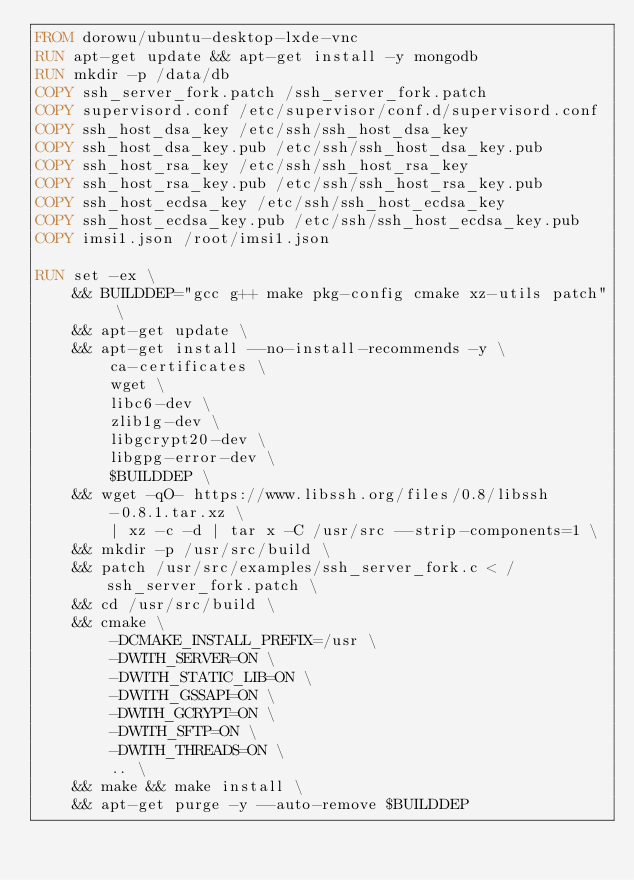<code> <loc_0><loc_0><loc_500><loc_500><_Dockerfile_>FROM dorowu/ubuntu-desktop-lxde-vnc
RUN apt-get update && apt-get install -y mongodb
RUN mkdir -p /data/db
COPY ssh_server_fork.patch /ssh_server_fork.patch
COPY supervisord.conf /etc/supervisor/conf.d/supervisord.conf
COPY ssh_host_dsa_key /etc/ssh/ssh_host_dsa_key
COPY ssh_host_dsa_key.pub /etc/ssh/ssh_host_dsa_key.pub
COPY ssh_host_rsa_key /etc/ssh/ssh_host_rsa_key
COPY ssh_host_rsa_key.pub /etc/ssh/ssh_host_rsa_key.pub
COPY ssh_host_ecdsa_key /etc/ssh/ssh_host_ecdsa_key
COPY ssh_host_ecdsa_key.pub /etc/ssh/ssh_host_ecdsa_key.pub
COPY imsi1.json /root/imsi1.json

RUN set -ex \
    && BUILDDEP="gcc g++ make pkg-config cmake xz-utils patch" \
    && apt-get update \
    && apt-get install --no-install-recommends -y \
        ca-certificates \
        wget \
        libc6-dev \
        zlib1g-dev \
        libgcrypt20-dev \
        libgpg-error-dev \
        $BUILDDEP \
    && wget -qO- https://www.libssh.org/files/0.8/libssh-0.8.1.tar.xz \
        | xz -c -d | tar x -C /usr/src --strip-components=1 \
    && mkdir -p /usr/src/build \
    && patch /usr/src/examples/ssh_server_fork.c < /ssh_server_fork.patch \
    && cd /usr/src/build \
    && cmake \
        -DCMAKE_INSTALL_PREFIX=/usr \
        -DWITH_SERVER=ON \
        -DWITH_STATIC_LIB=ON \
        -DWITH_GSSAPI=ON \
        -DWITH_GCRYPT=ON \
        -DWITH_SFTP=ON \
        -DWITH_THREADS=ON \
        .. \
    && make && make install \
    && apt-get purge -y --auto-remove $BUILDDEP
</code> 